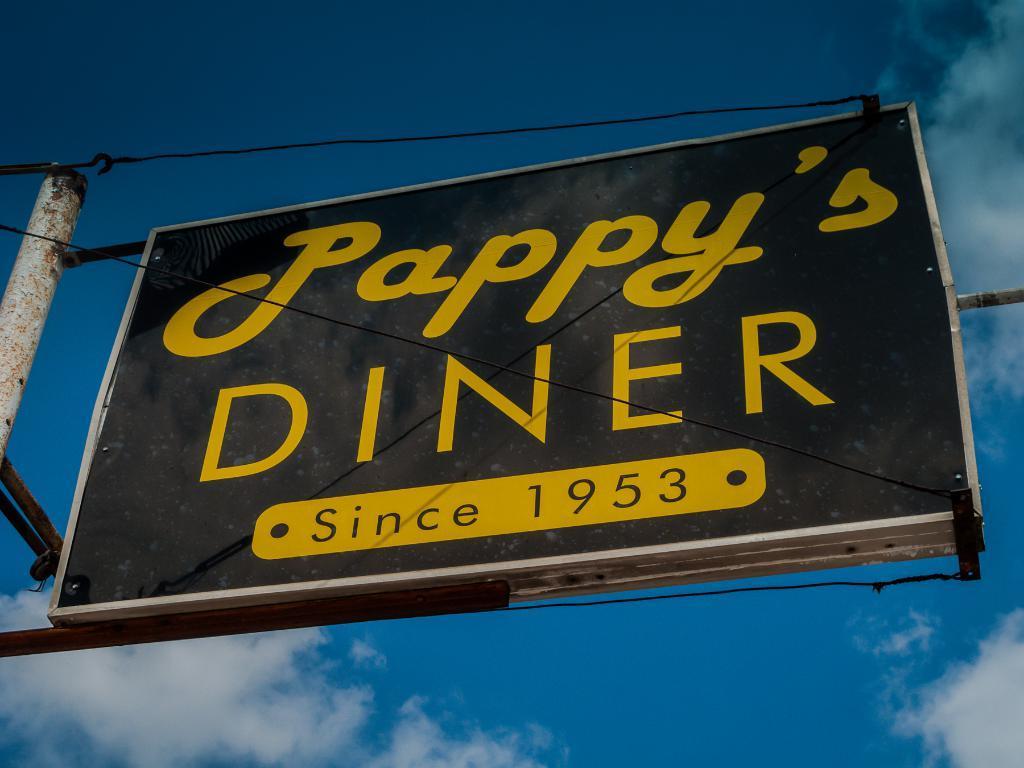How would you summarize this image in a sentence or two? In the middle of the image there is a black color name board with a name and a year on it. To the board there are few wires. To the left corner of the image there is a pole. 